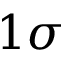Convert formula to latex. <formula><loc_0><loc_0><loc_500><loc_500>1 \sigma</formula> 